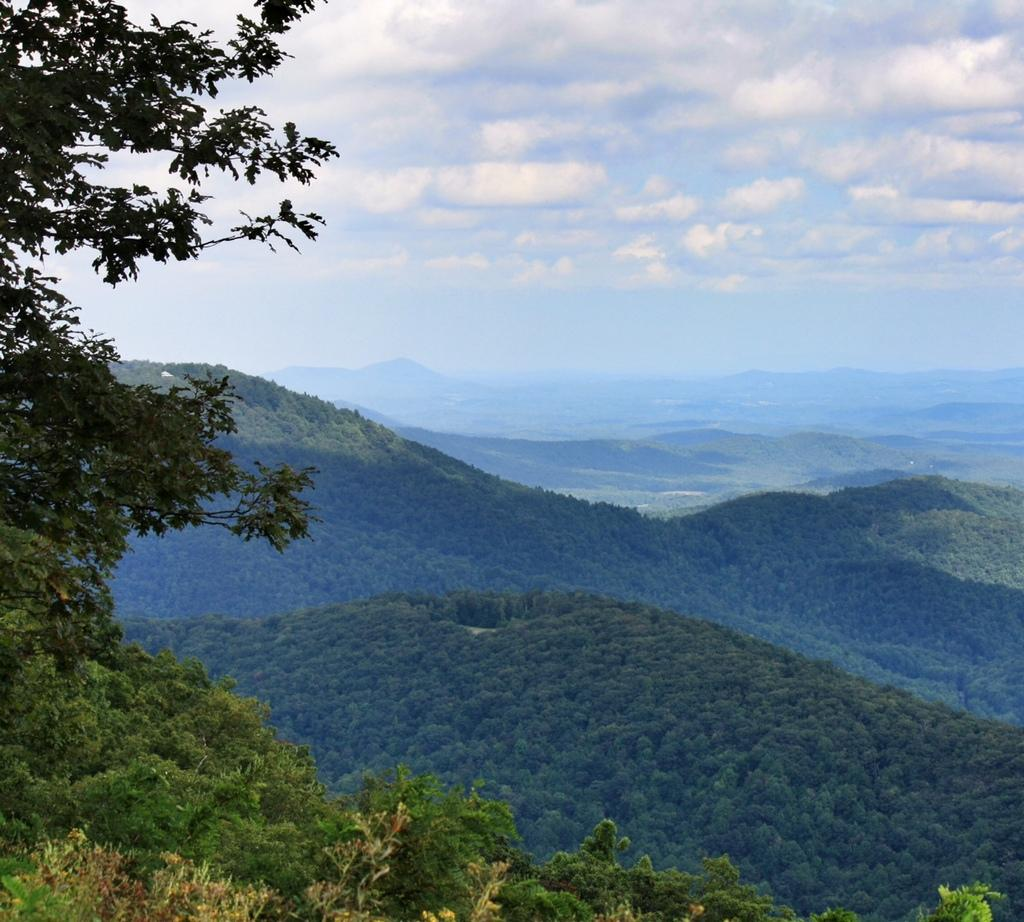What type of vegetation is present in the image? There are many trees in the image. What can be seen in the distance in the image? There are mountains in the background of the image. What else is visible in the background of the image? There are clouds and the sky in the background of the image. What type of mint can be seen growing among the trees in the image? There is no mint visible in the image; it only features trees, mountains, clouds, and the sky. 